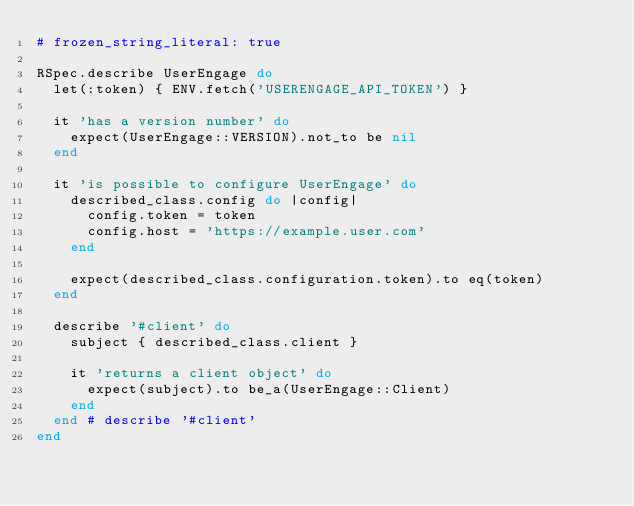Convert code to text. <code><loc_0><loc_0><loc_500><loc_500><_Ruby_># frozen_string_literal: true

RSpec.describe UserEngage do
  let(:token) { ENV.fetch('USERENGAGE_API_TOKEN') }

  it 'has a version number' do
    expect(UserEngage::VERSION).not_to be nil
  end

  it 'is possible to configure UserEngage' do
    described_class.config do |config|
      config.token = token
      config.host = 'https://example.user.com'
    end

    expect(described_class.configuration.token).to eq(token)
  end

  describe '#client' do
    subject { described_class.client }

    it 'returns a client object' do
      expect(subject).to be_a(UserEngage::Client)
    end
  end # describe '#client'
end
</code> 